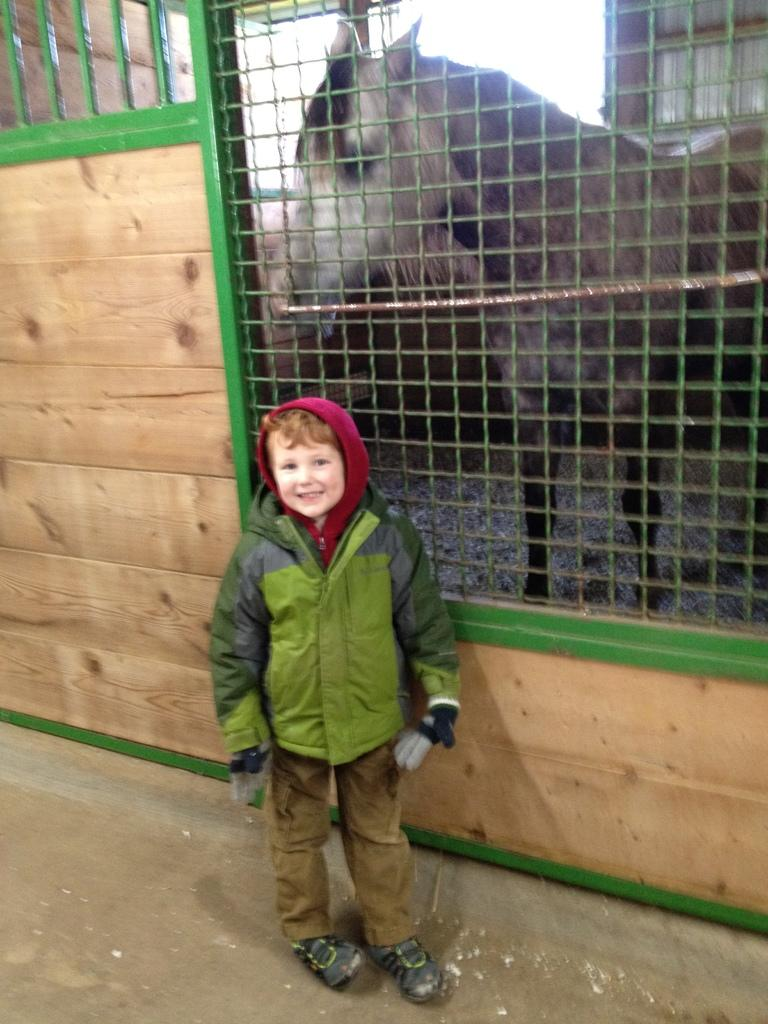Who is present in the image? There is a boy in the image. What is the boy wearing? The boy is wearing a coat, gloves, trousers, and shoes. What can be seen behind the fencing in the image? There is a horse behind the fencing. What type of wall can be seen in the image? There is no wall present in the image; it features a boy wearing various items of clothing and a horse behind a fence. 